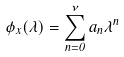<formula> <loc_0><loc_0><loc_500><loc_500>\phi _ { x } ( \lambda ) = \sum _ { n = 0 } ^ { \nu } a _ { n } \lambda ^ { n }</formula> 